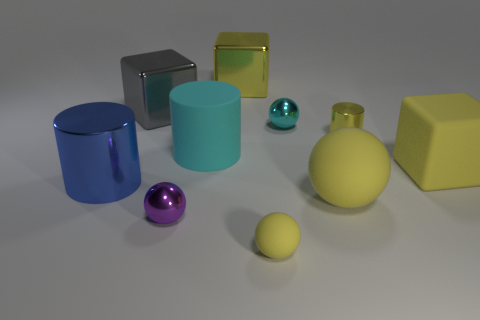Subtract all tiny spheres. How many spheres are left? 1 Subtract all cyan spheres. How many spheres are left? 3 Subtract all gray spheres. Subtract all cyan cylinders. How many spheres are left? 4 Subtract all cylinders. How many objects are left? 7 Subtract 1 cyan cylinders. How many objects are left? 9 Subtract all gray shiny things. Subtract all rubber cubes. How many objects are left? 8 Add 1 purple metal objects. How many purple metal objects are left? 2 Add 3 tiny cyan shiny cylinders. How many tiny cyan shiny cylinders exist? 3 